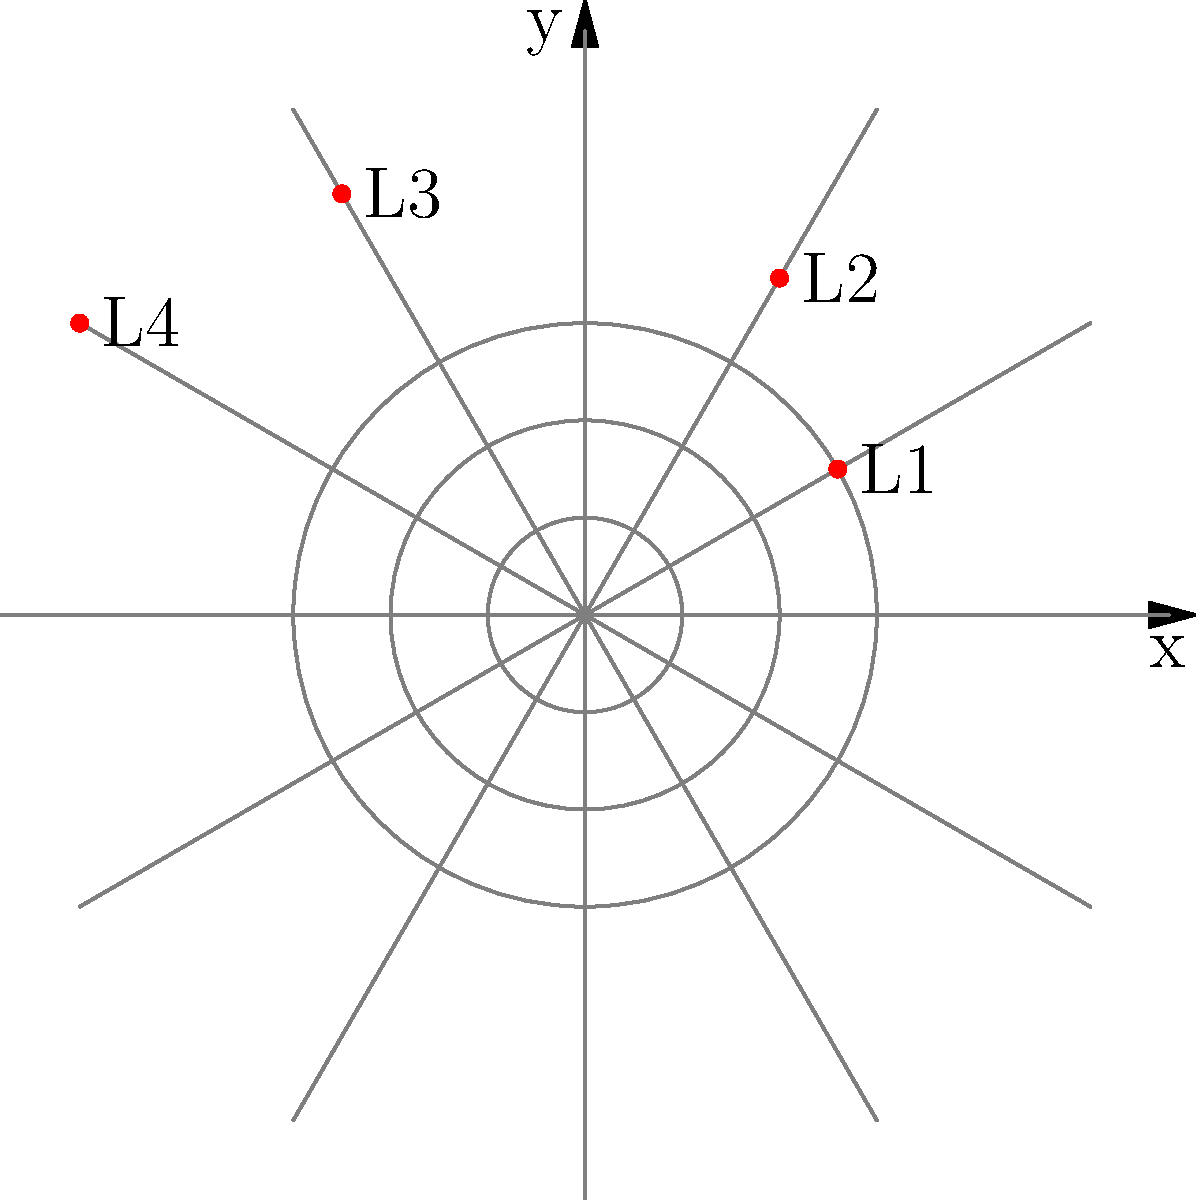In a secret operation to map hidden libraries in North Korea, four locations (L1, L2, L3, L4) are plotted on a polar grid. Their coordinates are:
L1: $(3, \frac{\pi}{6})$, L2: $(4, \frac{\pi}{3})$, L3: $(5, \frac{2\pi}{3})$, L4: $(6, \frac{5\pi}{6})$
What is the distance between the two farthest libraries, rounded to two decimal places? To find the distance between the two farthest libraries, we need to calculate the distance between each pair of libraries and find the maximum. We'll use the distance formula in polar coordinates:

$d = \sqrt{r_1^2 + r_2^2 - 2r_1r_2\cos(\theta_2 - \theta_1)}$

Step 1: Calculate distances between all pairs:

L1 to L2: $d_{12} = \sqrt{3^2 + 4^2 - 2(3)(4)\cos(\frac{\pi}{3} - \frac{\pi}{6})} = \sqrt{25 - 24\cos(\frac{\pi}{6})} \approx 1.93$

L1 to L3: $d_{13} = \sqrt{3^2 + 5^2 - 2(3)(5)\cos(\frac{2\pi}{3} - \frac{\pi}{6})} = \sqrt{34 - 30\cos(\frac{\pi}{2})} = \sqrt{34} \approx 5.83$

L1 to L4: $d_{14} = \sqrt{3^2 + 6^2 - 2(3)(6)\cos(\frac{5\pi}{6} - \frac{\pi}{6})} = \sqrt{45 - 36\cos(\frac{2\pi}{3})} = \sqrt{63} \approx 7.94$

L2 to L3: $d_{23} = \sqrt{4^2 + 5^2 - 2(4)(5)\cos(\frac{2\pi}{3} - \frac{\pi}{3})} = \sqrt{41 - 40\cos(\frac{\pi}{3})} \approx 3.61$

L2 to L4: $d_{24} = \sqrt{4^2 + 6^2 - 2(4)(6)\cos(\frac{5\pi}{6} - \frac{\pi}{3})} = \sqrt{52 - 48\cos(\frac{\pi}{2})} = \sqrt{52} \approx 7.21$

L3 to L4: $d_{34} = \sqrt{5^2 + 6^2 - 2(5)(6)\cos(\frac{5\pi}{6} - \frac{2\pi}{3})} = \sqrt{61 - 60\cos(\frac{\pi}{6})} \approx 2.24$

Step 2: Find the maximum distance
The maximum distance is between L1 and L4, which is $\sqrt{63} \approx 7.94$.

Step 3: Round to two decimal places
$7.94$ rounded to two decimal places is $7.94$.
Answer: 7.94 